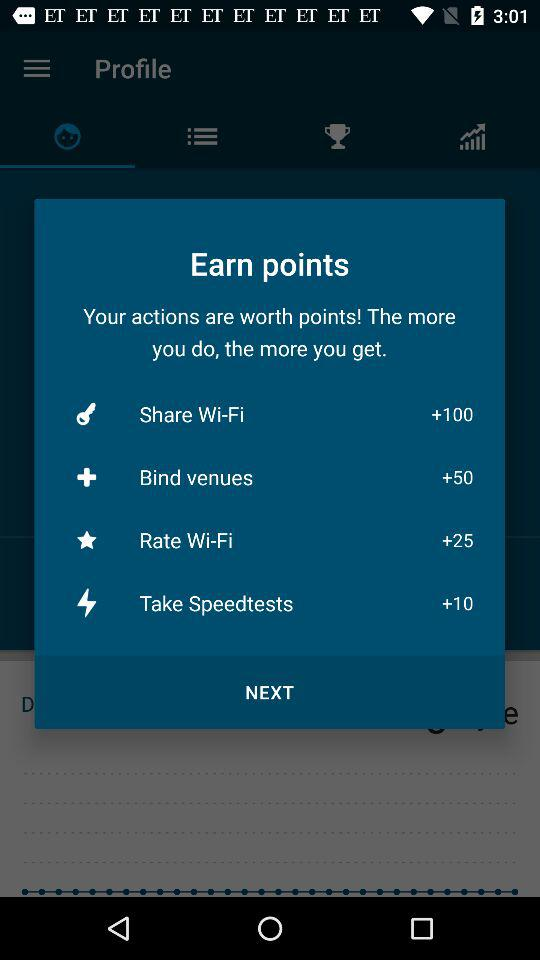Are there any other ways to earn points that aren't listed on this screen? The screen shows the primary actions rewarded with points: sharing Wi-Fi, binding venues, rating Wi-Fi, and taking speed tests. There could be additional ways to earn points not displayed here, such as special promotions or bonuses. It's recommended to check the app's terms or updates for more opportunities to earn points. 